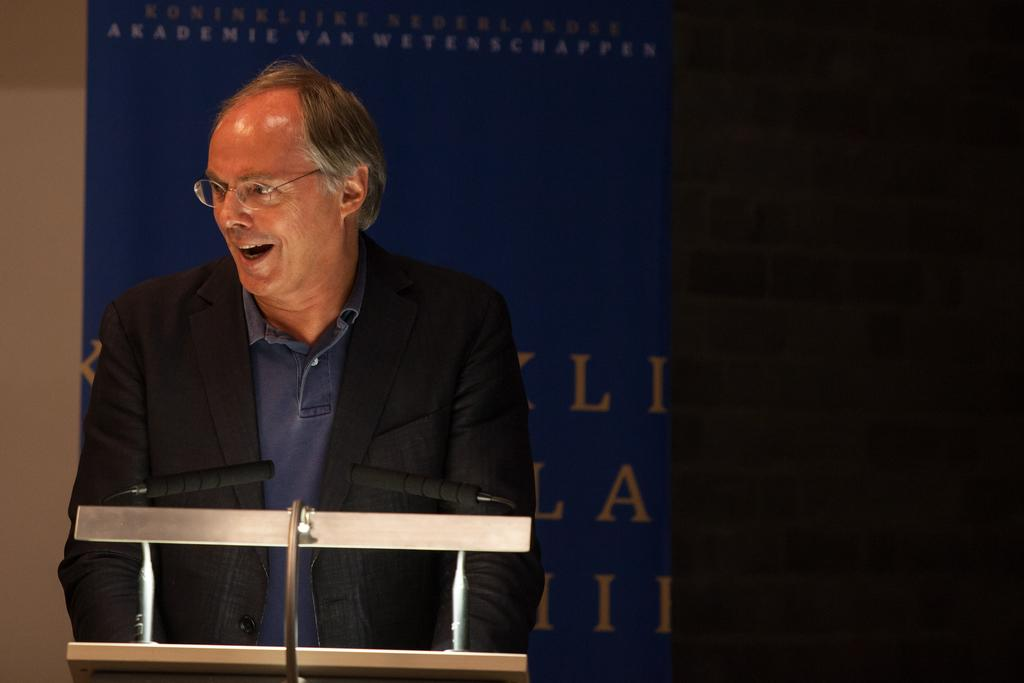What is the main subject of the image? There is a man standing in the image. Can you describe the man's appearance? The man is wearing spectacles. What direction is the man looking in? The man is looking to the left side. What objects can be seen in the image besides the man? There are microphones in the image. What is visible in the background of the image? There is a banner in the background of the image. Can you tell me what type of bird is sitting on the man's shoulder in the image? There is no bird present in the image; the man is standing alone. What book is the man holding in the image? There is no book visible in the image; the man is not holding anything. 